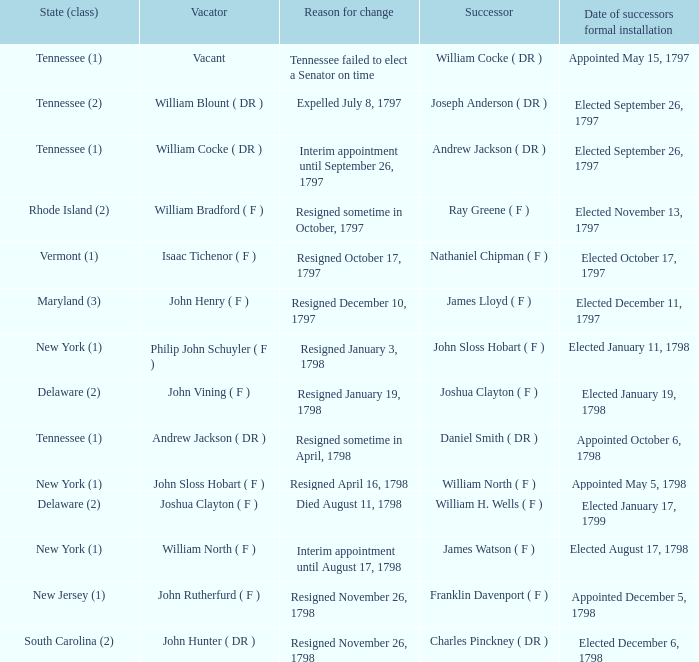What is the number of vacators when the successor was William H. Wells ( F )? 1.0. 